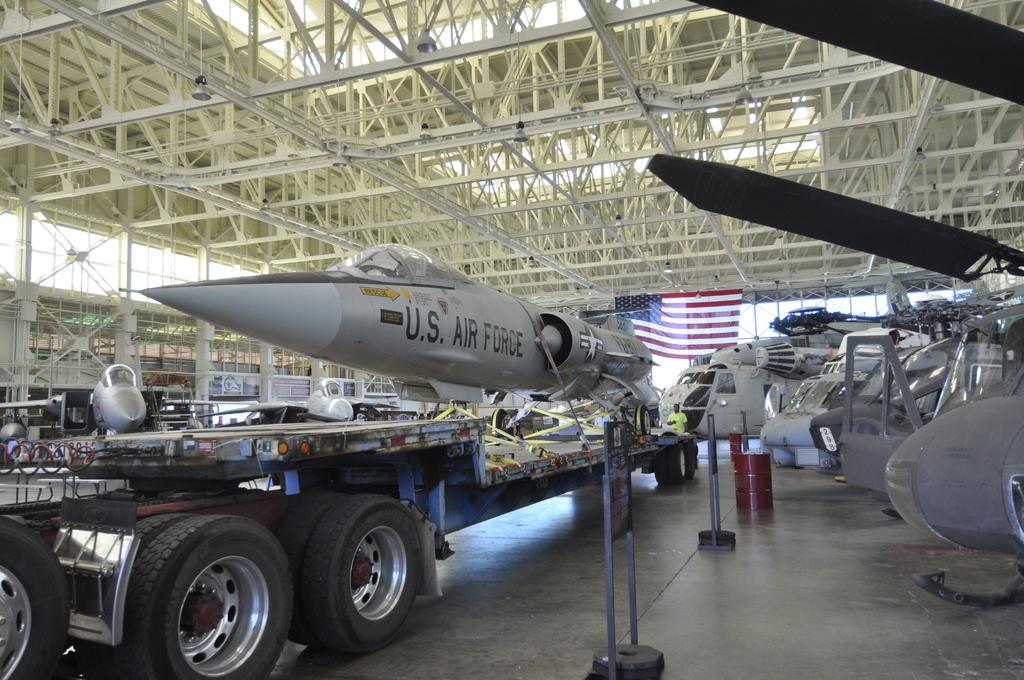What does it say on the jet?
Ensure brevity in your answer.  Us air force. What branch of the military is the plane from?
Keep it short and to the point. Air force. 